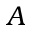Convert formula to latex. <formula><loc_0><loc_0><loc_500><loc_500>A</formula> 